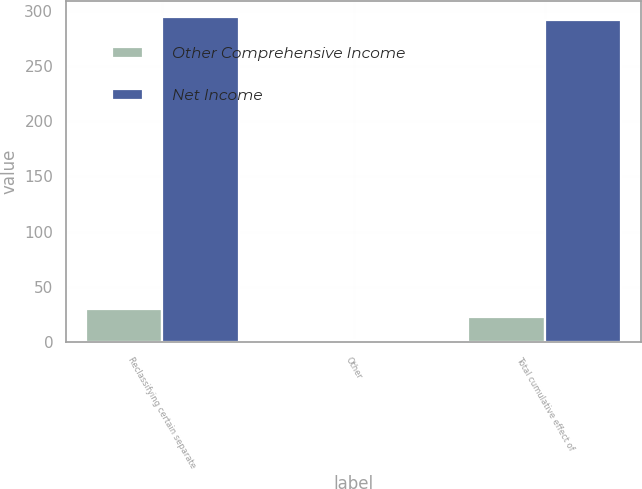Convert chart. <chart><loc_0><loc_0><loc_500><loc_500><stacked_bar_chart><ecel><fcel>Reclassifying certain separate<fcel>Other<fcel>Total cumulative effect of<nl><fcel>Other Comprehensive Income<fcel>30<fcel>1<fcel>23<nl><fcel>Net Income<fcel>294<fcel>2<fcel>292<nl></chart> 